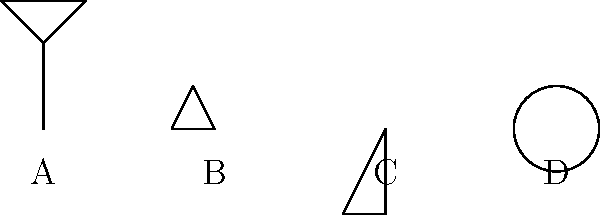Ancient Egyptian hieroglyphs are often found in various orientations. In the image above, four hieroglyphs (A, B, C, and D) are shown in different rotations. To form a complete message, each hieroglyph needs to be rotated to its correct orientation. How many total degrees of rotation (clockwise) are required to orient all the hieroglyphs correctly? To solve this problem, we need to analyze each hieroglyph and determine the rotation required to orient it correctly:

1. Hieroglyph A (Ankh): Already in the correct orientation. Rotation needed: 0°

2. Hieroglyph B (Eye of Horus): Currently rotated 90° clockwise. To correct it, we need to rotate it 270° clockwise (or 90° counterclockwise). Rotation needed: 270°

3. Hieroglyph C (Feather of Maat): Currently rotated 180°. To correct it, we need to rotate it 180° clockwise. Rotation needed: 180°

4. Hieroglyph D (Sun disk): Currently rotated 270° clockwise. To correct it, we need to rotate it 90° clockwise. Rotation needed: 90°

Now, we sum up all the rotations:
$$ \text{Total rotation} = 0° + 270° + 180° + 90° = 540° $$

Therefore, the total clockwise rotation required to orient all hieroglyphs correctly is 540°.
Answer: 540° 